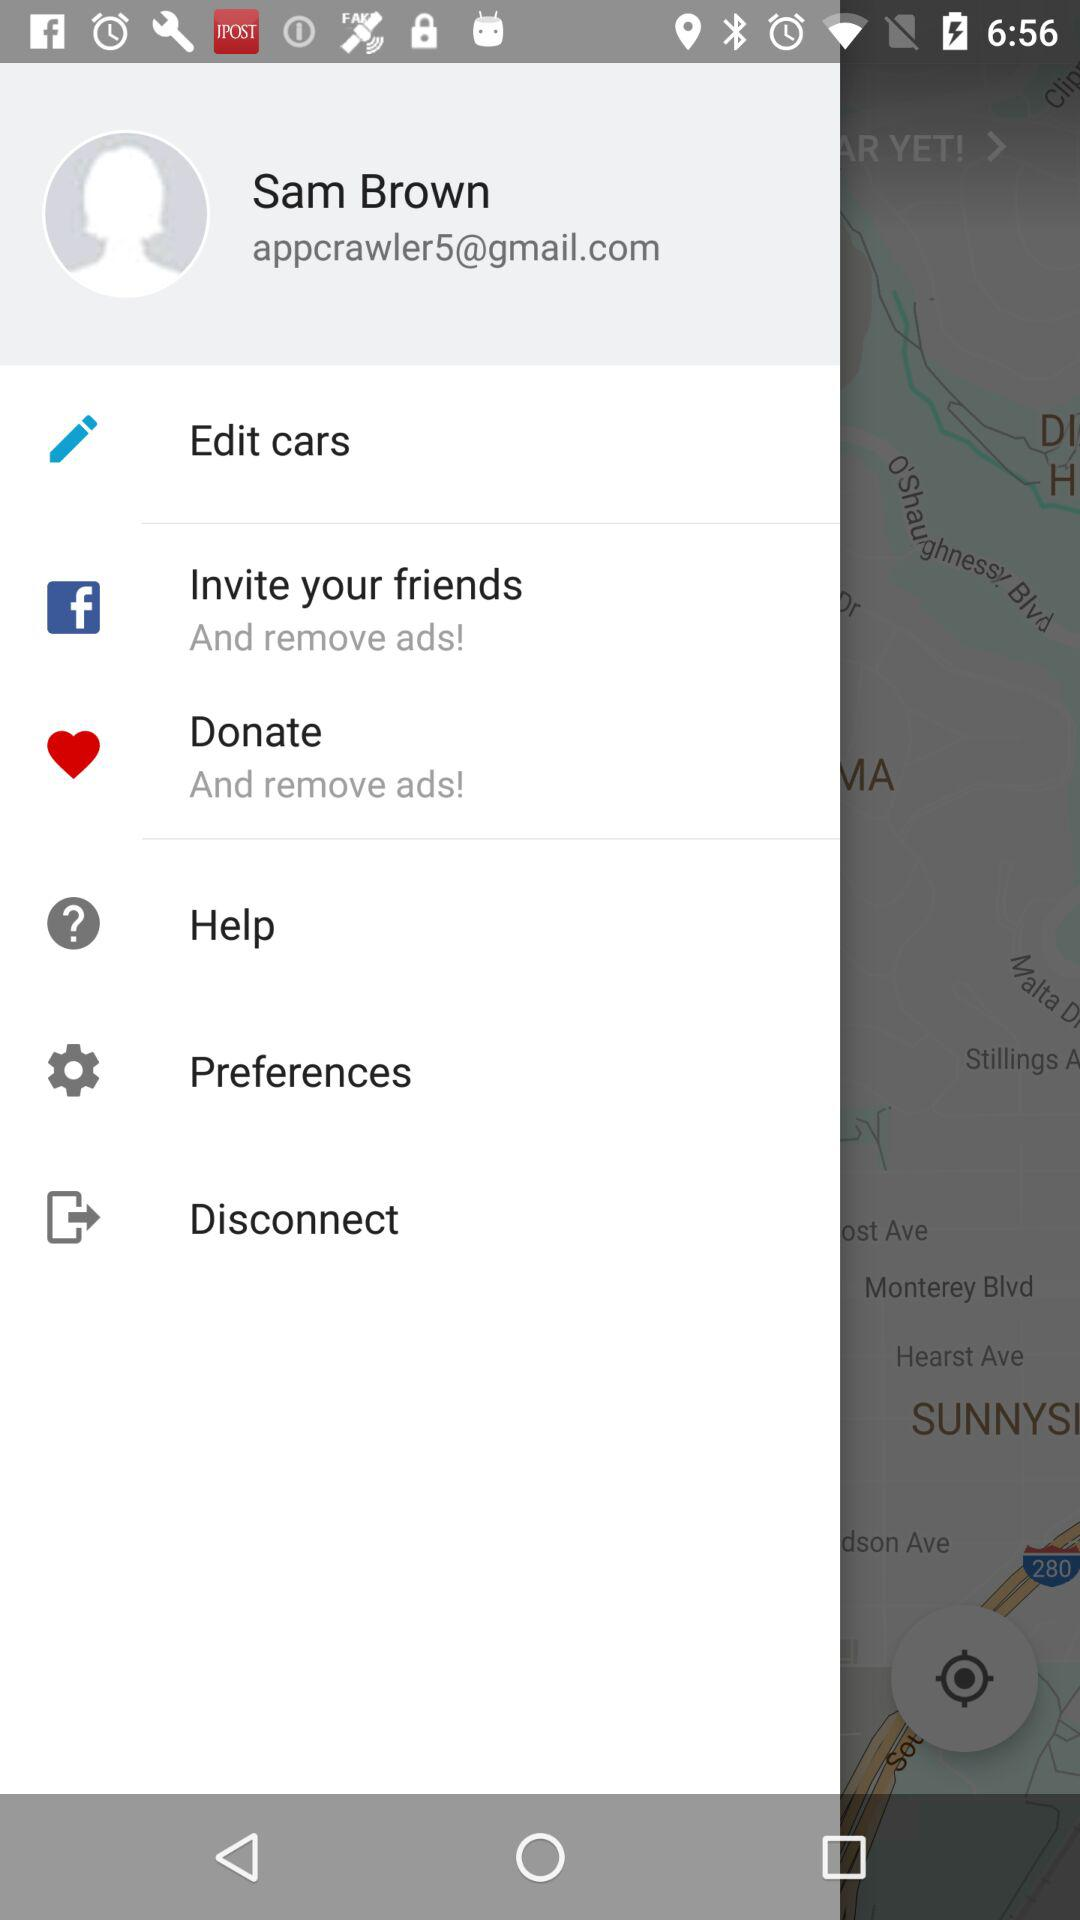What are the options to remove the ads? The options are "Invite your friends" and "Donate". 